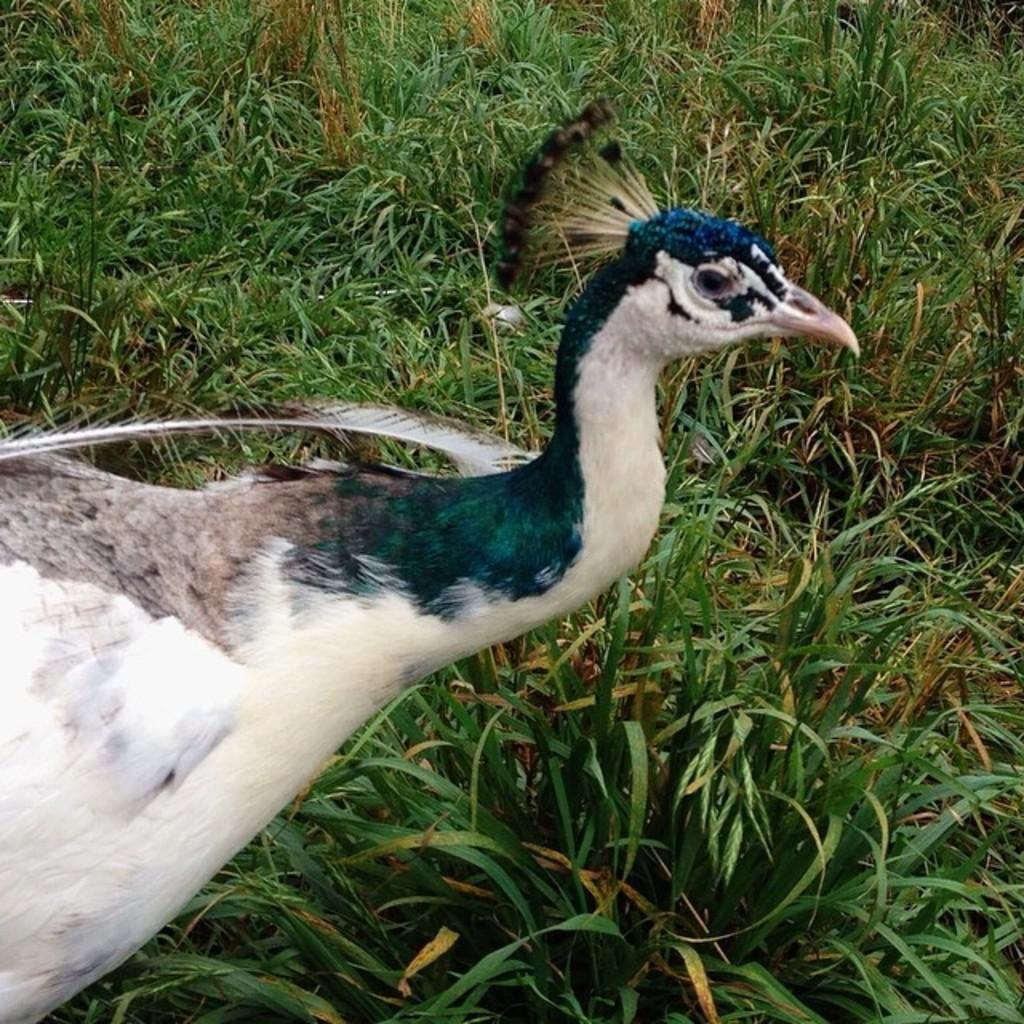What type of animal is in the image? There is a peacock in the image. What is the background of the image? There is grass at the bottom of the image. What type of print can be seen on the peacock's feathers in the image? There is no print visible on the peacock's feathers in the image; the peacock's feathers have a natural pattern. 